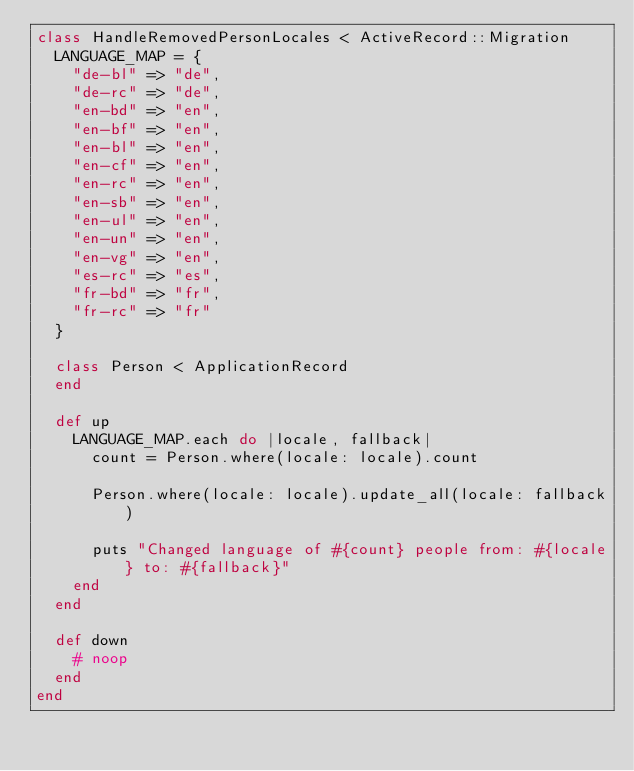<code> <loc_0><loc_0><loc_500><loc_500><_Ruby_>class HandleRemovedPersonLocales < ActiveRecord::Migration
  LANGUAGE_MAP = {
    "de-bl" => "de",
    "de-rc" => "de",
    "en-bd" => "en",
    "en-bf" => "en",
    "en-bl" => "en",
    "en-cf" => "en",
    "en-rc" => "en",
    "en-sb" => "en",
    "en-ul" => "en",
    "en-un" => "en",
    "en-vg" => "en",
    "es-rc" => "es",
    "fr-bd" => "fr",
    "fr-rc" => "fr"
  }

  class Person < ApplicationRecord
  end

  def up
    LANGUAGE_MAP.each do |locale, fallback|
      count = Person.where(locale: locale).count

      Person.where(locale: locale).update_all(locale: fallback)

      puts "Changed language of #{count} people from: #{locale} to: #{fallback}"
    end
  end

  def down
    # noop
  end
end
</code> 